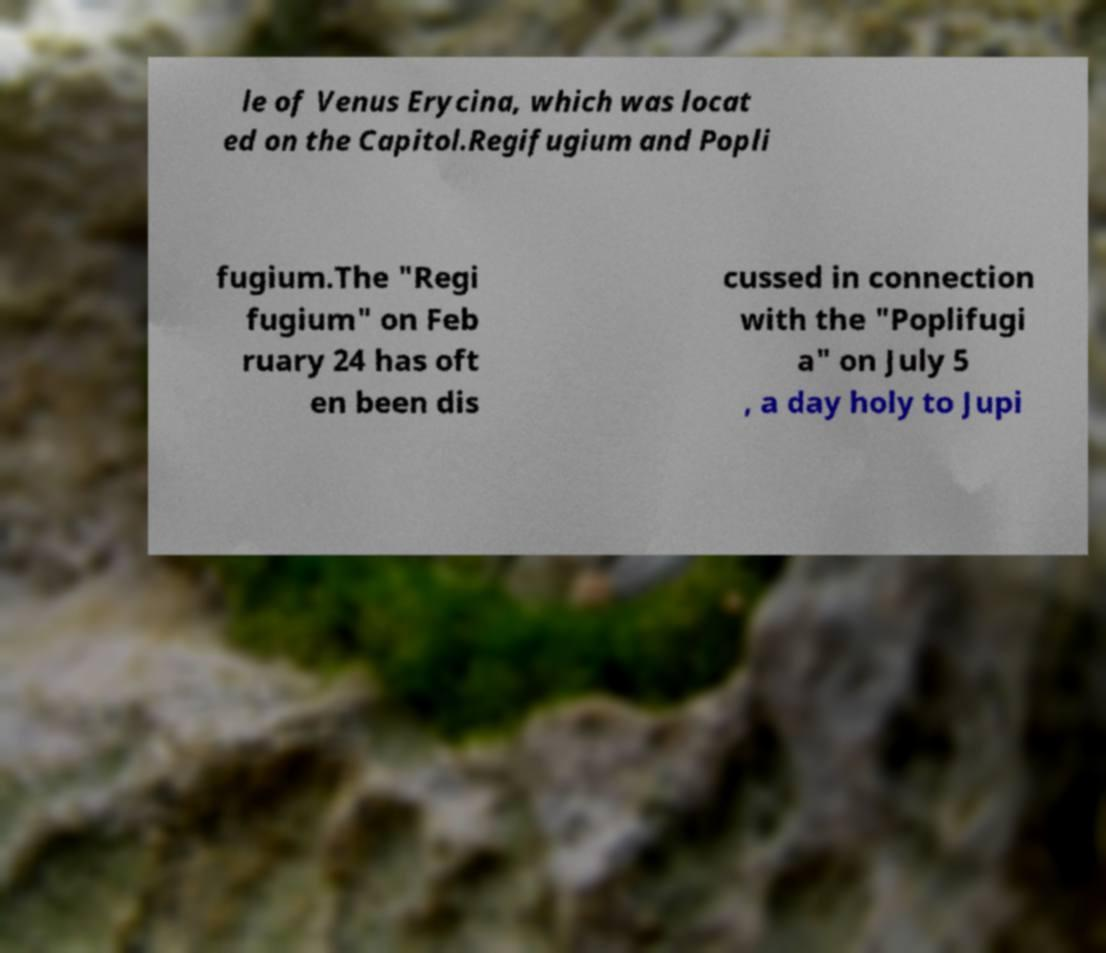What messages or text are displayed in this image? I need them in a readable, typed format. le of Venus Erycina, which was locat ed on the Capitol.Regifugium and Popli fugium.The "Regi fugium" on Feb ruary 24 has oft en been dis cussed in connection with the "Poplifugi a" on July 5 , a day holy to Jupi 